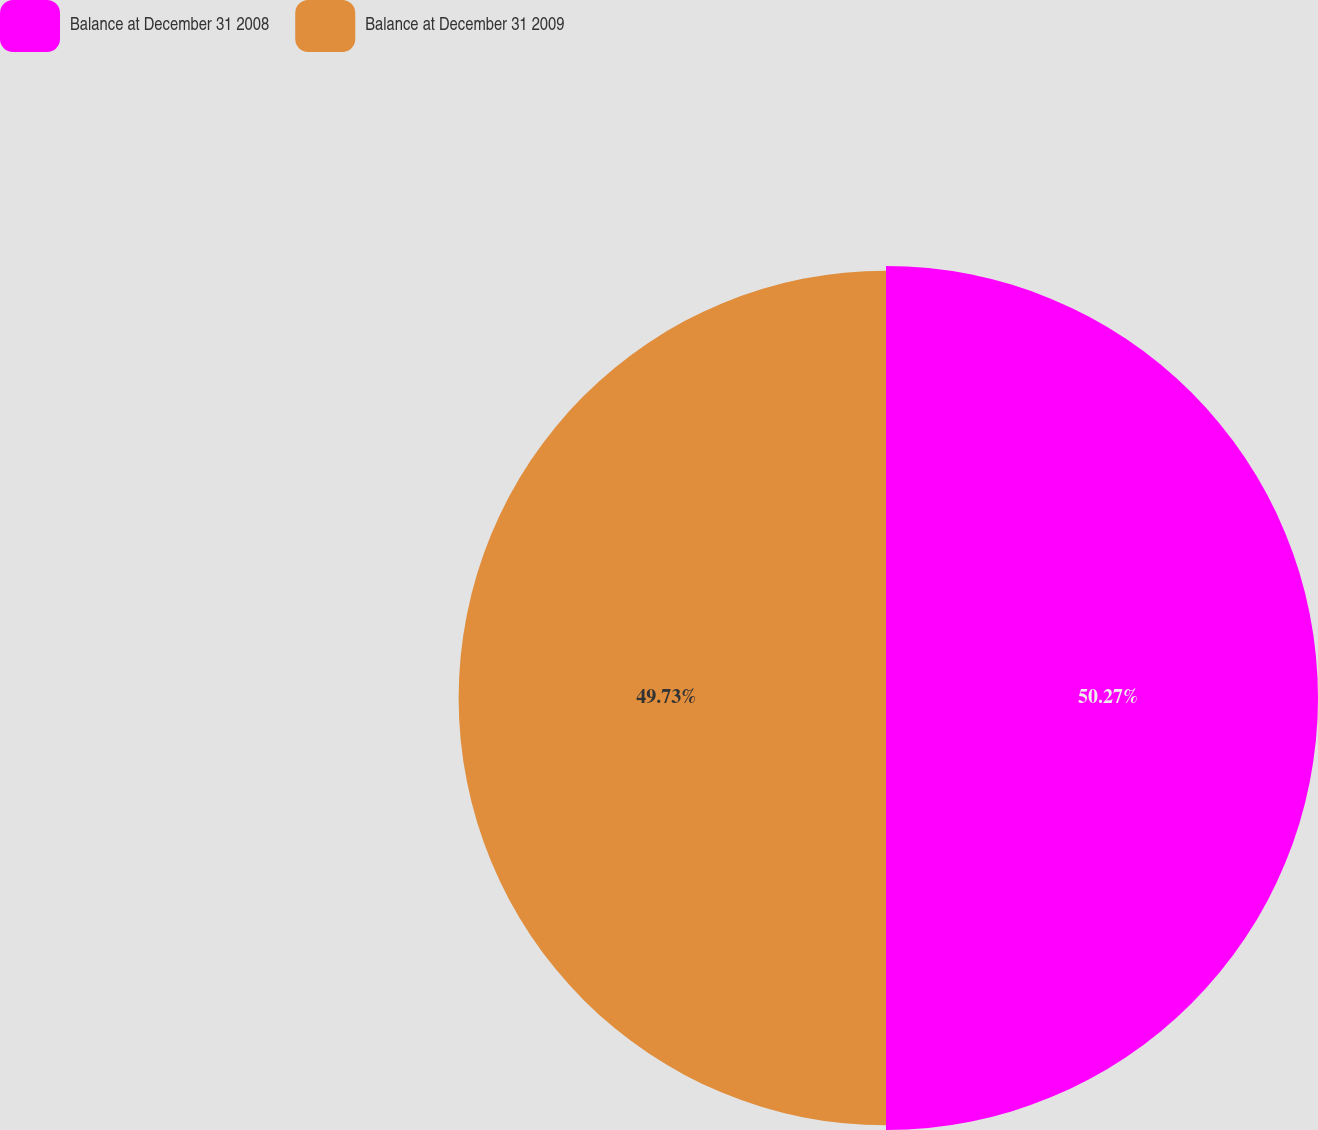<chart> <loc_0><loc_0><loc_500><loc_500><pie_chart><fcel>Balance at December 31 2008<fcel>Balance at December 31 2009<nl><fcel>50.27%<fcel>49.73%<nl></chart> 